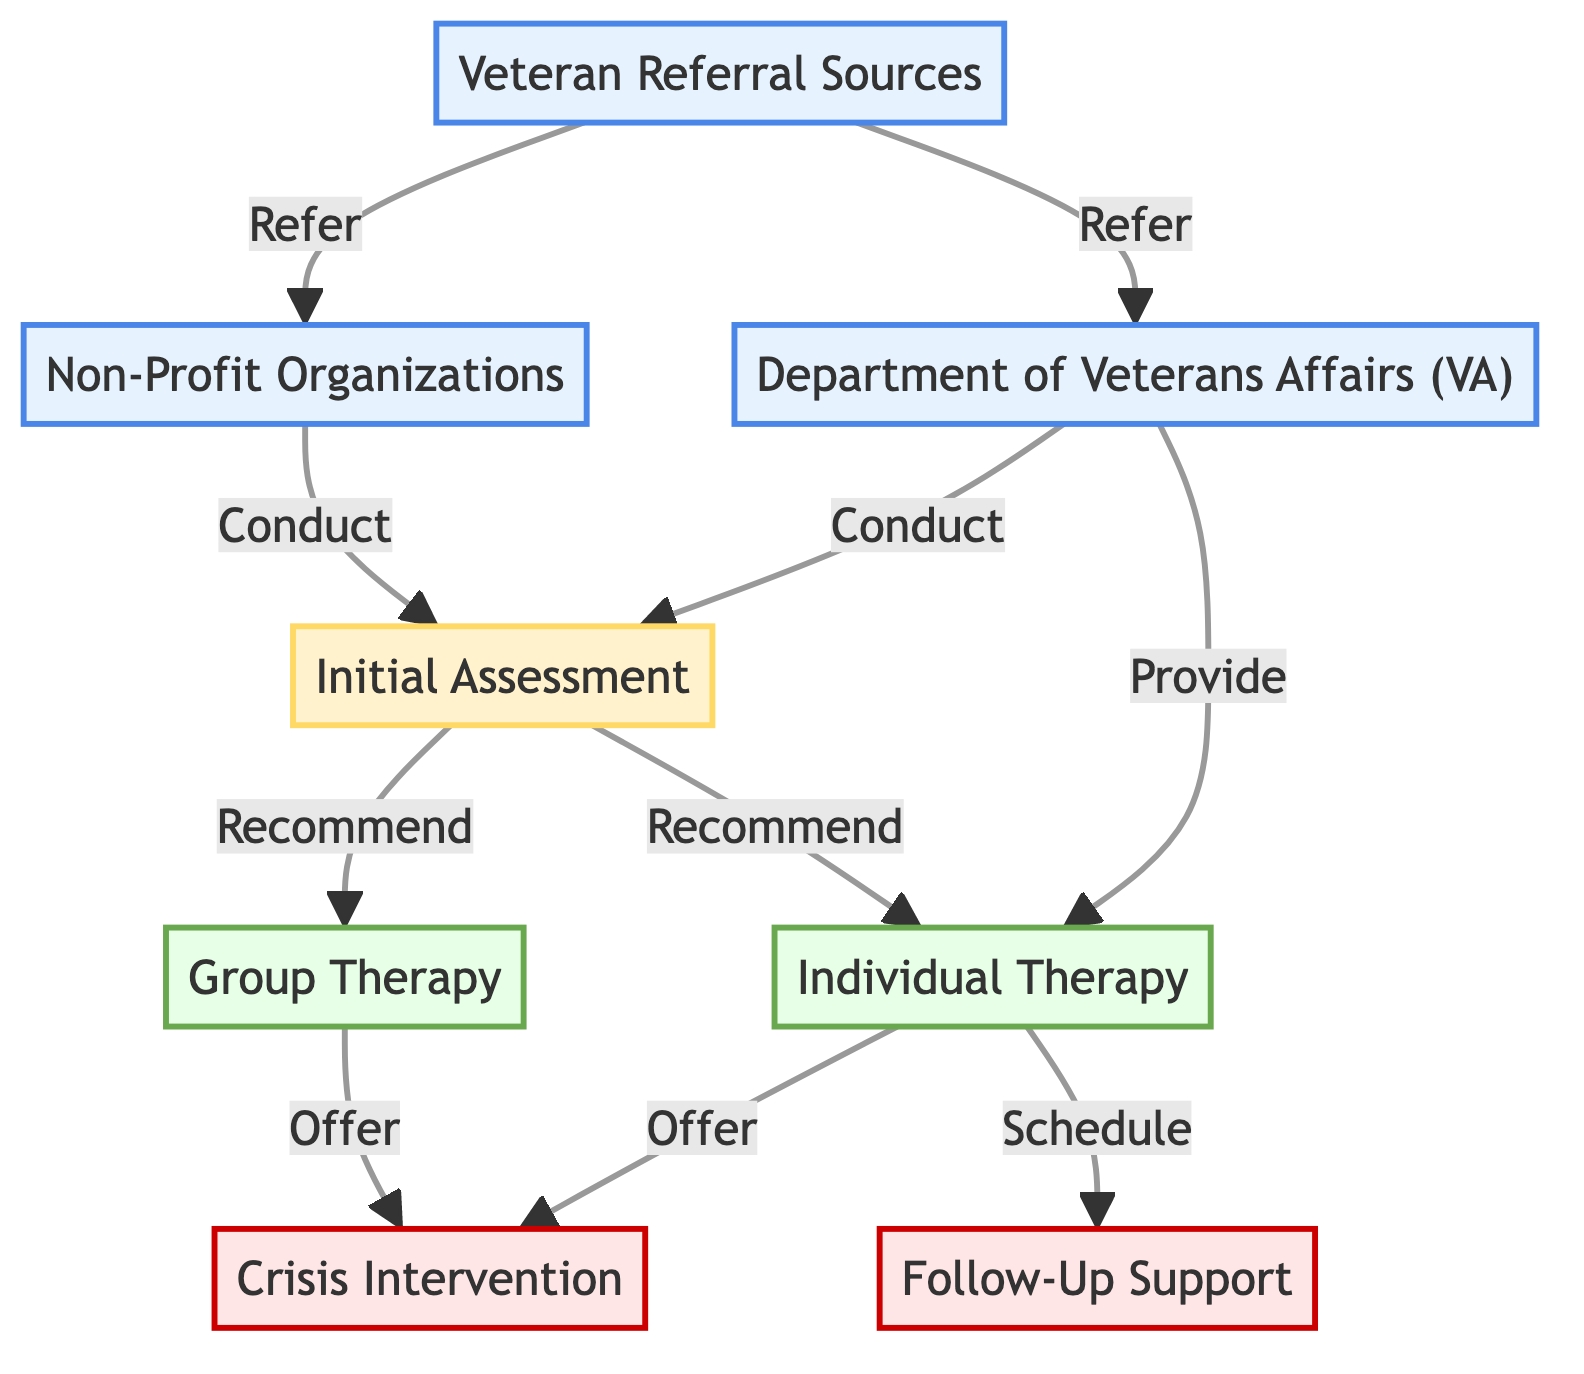What are the sources that refer veterans to support services? The diagram identifies "Veteran Referral Sources" as the starting point, which includes organizations and individuals. From this node, there are direct arrows pointing to "Department of Veterans Affairs (VA)" and "Non-Profit Organizations," indicating these are the main sources for referrals.
Answer: Veteran Referral Sources How many main types of therapy are offered after the initial assessment? To answer this, we look at the "Initial Assessment" which leads to either "Individual Therapy" or "Group Therapy." Thus, there are two distinct therapy types available following the assessment.
Answer: 2 What is the purpose of the "Initial Assessment"? In the diagram, the "Initial Assessment" node states it is an evaluation process. Since the next steps from this node are to recommend individual or group therapy, it is clear that the assessment aims to understand the mental health needs of the veterans.
Answer: Evaluation process Which node offers follow-up support? The diagram indicates that "Follow-Up Support" is directly connected from "Individual Therapy" with an arrow stating 'Schedule'. This definitively shows that follow-up support is tied to individual therapy sessions.
Answer: Follow-Up Support How does the "Department of Veterans Affairs" connect to other services? The "Department of Veterans Affairs" is connected to both the "Initial Assessment" and "Individual Therapy." This indicates that the VA not only conducts assessments but also directly provides therapy sessions.
Answer: Initial Assessment and Individual Therapy What immediate support is provided for veterans in acute distress? The diagram outlines that "Crisis Intervention" is a node that follows from both "Individual Therapy" and "Group Therapy." Since it describes immediate support for veterans, it represents an accessible resource in times of distress.
Answer: Crisis Intervention What are the next steps after the "Initial Assessment"? Following the "Initial Assessment," the next possible steps are "Individual Therapy" and "Group Therapy" as indicated by the arrows leading from the assessment node to these therapy options. This shows the progression of care available to the veteran.
Answer: Individual Therapy and Group Therapy 